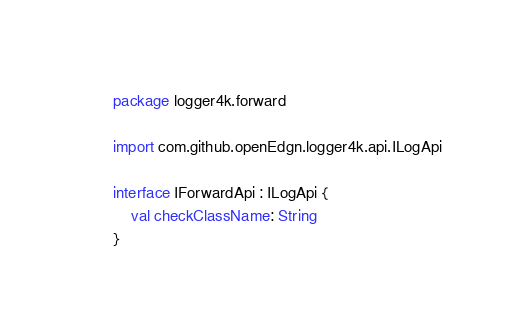<code> <loc_0><loc_0><loc_500><loc_500><_Kotlin_>package logger4k.forward

import com.github.openEdgn.logger4k.api.ILogApi

interface IForwardApi : ILogApi {
    val checkClassName: String
}
</code> 